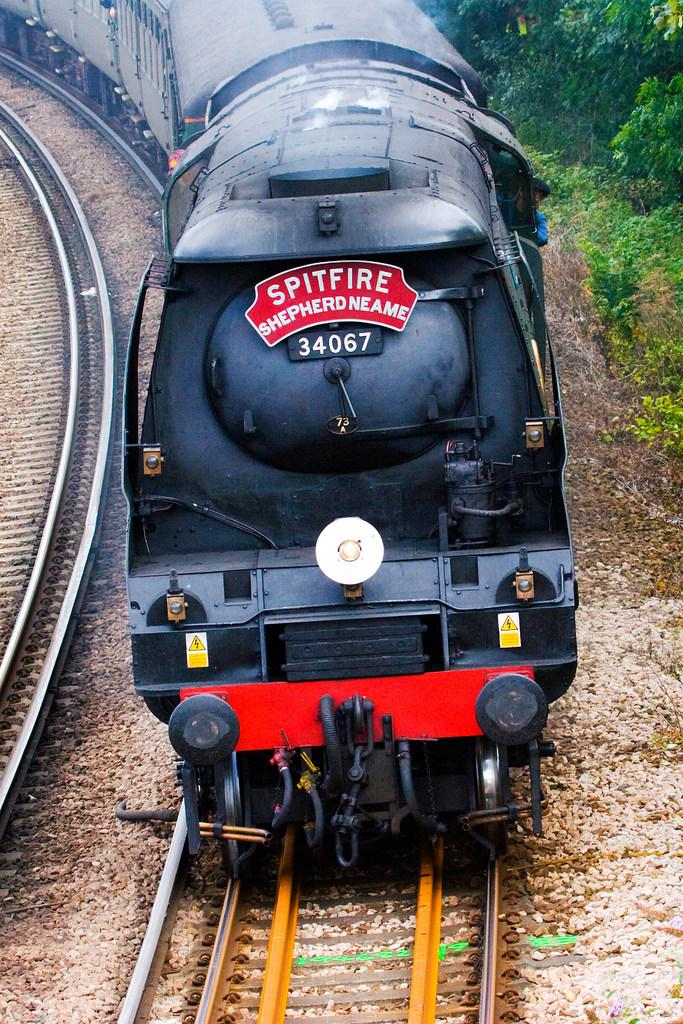What is the main subject of the image? There is a train in the image. Can you describe the train's position in the image? The train is on a track. What type of natural scenery can be seen in the image? There are trees visible in the top right of the image. What type of pest can be seen crawling on the train in the image? There is no pest visible on the train in the image. What type of liquid is being transported by the train in the image? There is no indication of any liquid being transported by the train in the image. 